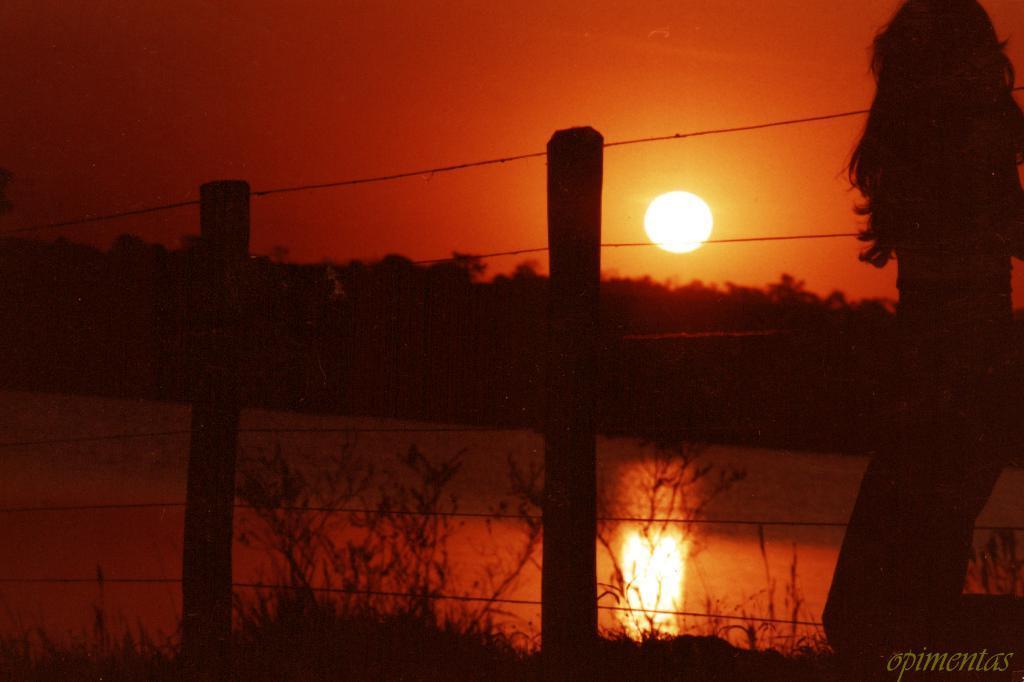Could you give a brief overview of what you see in this image? On the right of the image we can see a lady standing and there is a fence. In the background there is water, trees and sky. We can see the sun. At the bottom there is grass. 